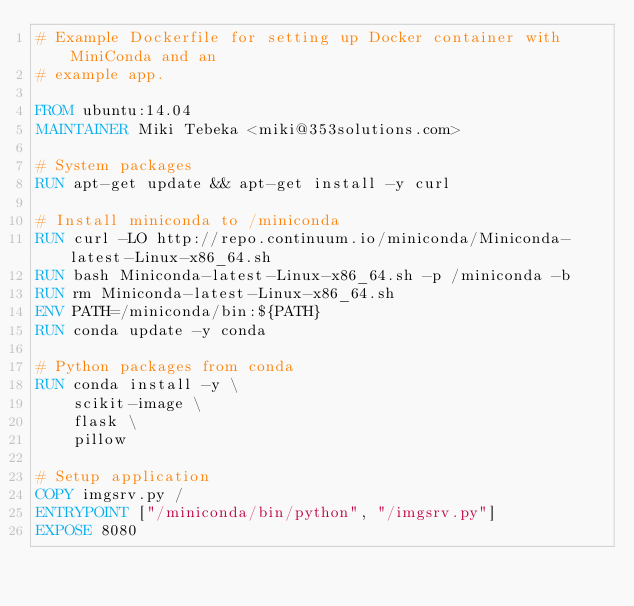Convert code to text. <code><loc_0><loc_0><loc_500><loc_500><_Dockerfile_># Example Dockerfile for setting up Docker container with MiniConda and an
# example app.

FROM ubuntu:14.04
MAINTAINER Miki Tebeka <miki@353solutions.com>

# System packages 
RUN apt-get update && apt-get install -y curl

# Install miniconda to /miniconda
RUN curl -LO http://repo.continuum.io/miniconda/Miniconda-latest-Linux-x86_64.sh
RUN bash Miniconda-latest-Linux-x86_64.sh -p /miniconda -b
RUN rm Miniconda-latest-Linux-x86_64.sh
ENV PATH=/miniconda/bin:${PATH}
RUN conda update -y conda

# Python packages from conda
RUN conda install -y \
    scikit-image \
    flask \
    pillow

# Setup application
COPY imgsrv.py /
ENTRYPOINT ["/miniconda/bin/python", "/imgsrv.py"]
EXPOSE 8080
</code> 